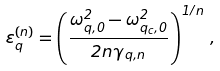<formula> <loc_0><loc_0><loc_500><loc_500>\varepsilon ^ { ( n ) } _ { q } = \left ( \frac { \omega _ { q , 0 } ^ { 2 } - \omega _ { q _ { c } , 0 } ^ { 2 } } { 2 n \gamma _ { q , n } } \right ) ^ { 1 / n } \, ,</formula> 